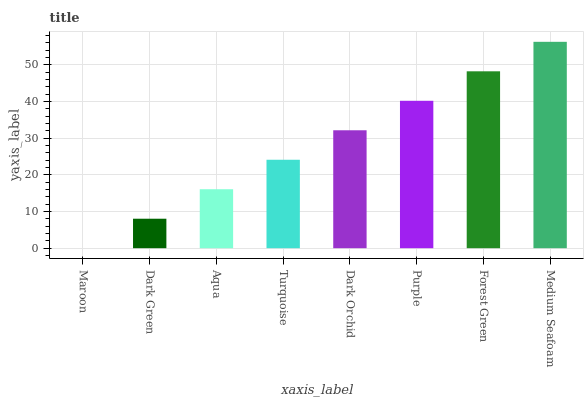Is Maroon the minimum?
Answer yes or no. Yes. Is Medium Seafoam the maximum?
Answer yes or no. Yes. Is Dark Green the minimum?
Answer yes or no. No. Is Dark Green the maximum?
Answer yes or no. No. Is Dark Green greater than Maroon?
Answer yes or no. Yes. Is Maroon less than Dark Green?
Answer yes or no. Yes. Is Maroon greater than Dark Green?
Answer yes or no. No. Is Dark Green less than Maroon?
Answer yes or no. No. Is Dark Orchid the high median?
Answer yes or no. Yes. Is Turquoise the low median?
Answer yes or no. Yes. Is Turquoise the high median?
Answer yes or no. No. Is Purple the low median?
Answer yes or no. No. 